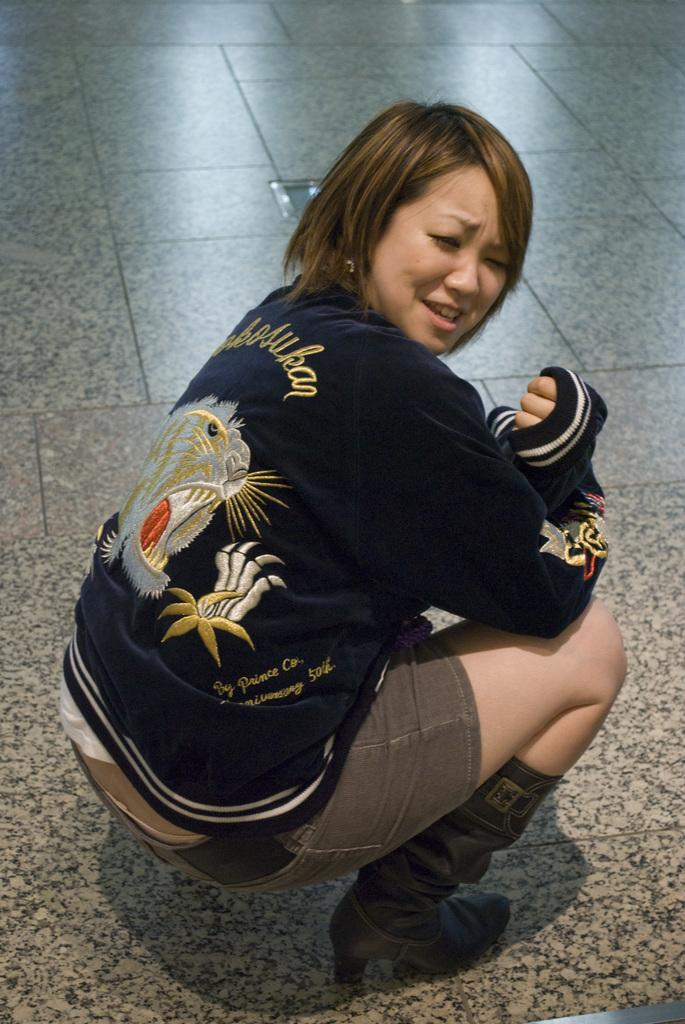What is present in the image? There is a person in the image. Can you describe the person's attire? The person is wearing a navy blue and grey color dress. What type of footwear is the person wearing? The person is wearing socks and shoes. Where is the person located in the image? The person is on the floor. What type of wool is being spun by the person in the image? There is no wool or spinning activity present in the image. 